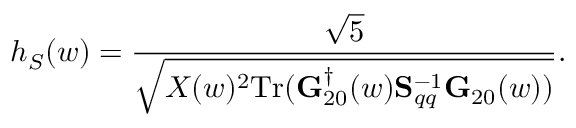Convert formula to latex. <formula><loc_0><loc_0><loc_500><loc_500>h _ { S } ( w ) = \frac { \sqrt { 5 } } { \sqrt { X ( w ) ^ { 2 } T r ( { G } _ { 2 0 } ^ { \dagger } ( w ) { S } _ { q q } ^ { - 1 } { G } _ { 2 0 } ( w ) ) } } .</formula> 